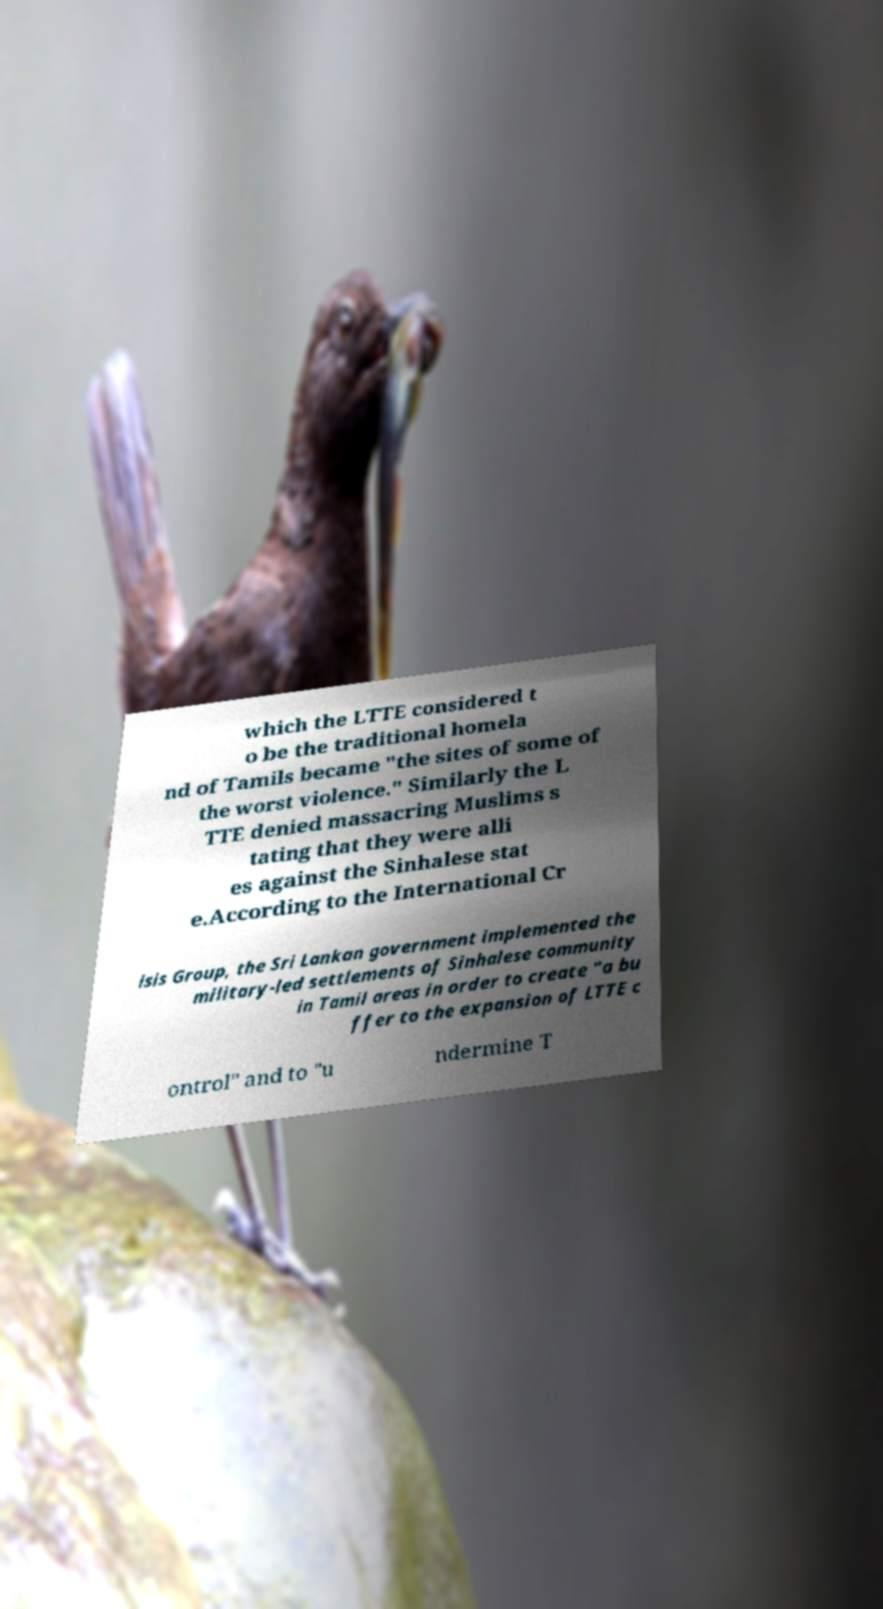Could you extract and type out the text from this image? which the LTTE considered t o be the traditional homela nd of Tamils became "the sites of some of the worst violence." Similarly the L TTE denied massacring Muslims s tating that they were alli es against the Sinhalese stat e.According to the International Cr isis Group, the Sri Lankan government implemented the military-led settlements of Sinhalese community in Tamil areas in order to create "a bu ffer to the expansion of LTTE c ontrol" and to "u ndermine T 